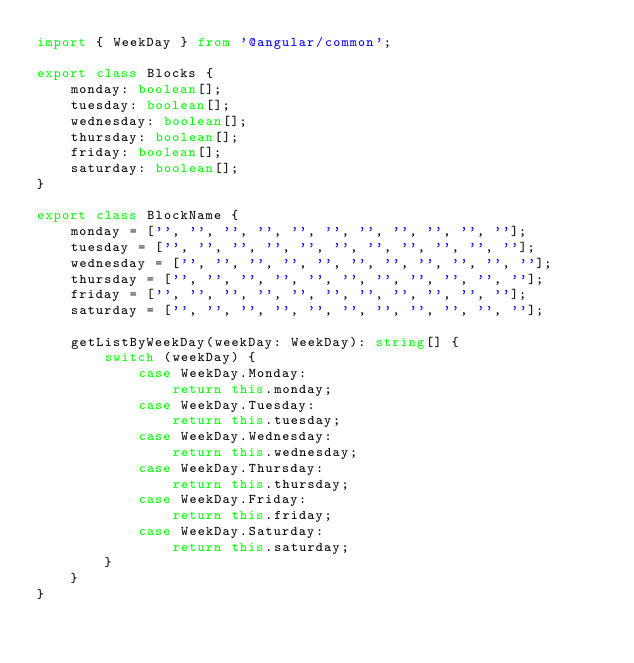Convert code to text. <code><loc_0><loc_0><loc_500><loc_500><_TypeScript_>import { WeekDay } from '@angular/common';

export class Blocks {
    monday: boolean[];
    tuesday: boolean[];
    wednesday: boolean[];
    thursday: boolean[];
    friday: boolean[];
    saturday: boolean[];
}

export class BlockName {
    monday = ['', '', '', '', '', '', '', '', '', '', ''];
    tuesday = ['', '', '', '', '', '', '', '', '', '', ''];
    wednesday = ['', '', '', '', '', '', '', '', '', '', ''];
    thursday = ['', '', '', '', '', '', '', '', '', '', ''];
    friday = ['', '', '', '', '', '', '', '', '', '', ''];
    saturday = ['', '', '', '', '', '', '', '', '', '', ''];

    getListByWeekDay(weekDay: WeekDay): string[] {
        switch (weekDay) {
            case WeekDay.Monday:
                return this.monday;
            case WeekDay.Tuesday:
                return this.tuesday;
            case WeekDay.Wednesday:
                return this.wednesday;
            case WeekDay.Thursday:
                return this.thursday;
            case WeekDay.Friday:
                return this.friday;
            case WeekDay.Saturday:
                return this.saturday;
        }
    }
}
</code> 